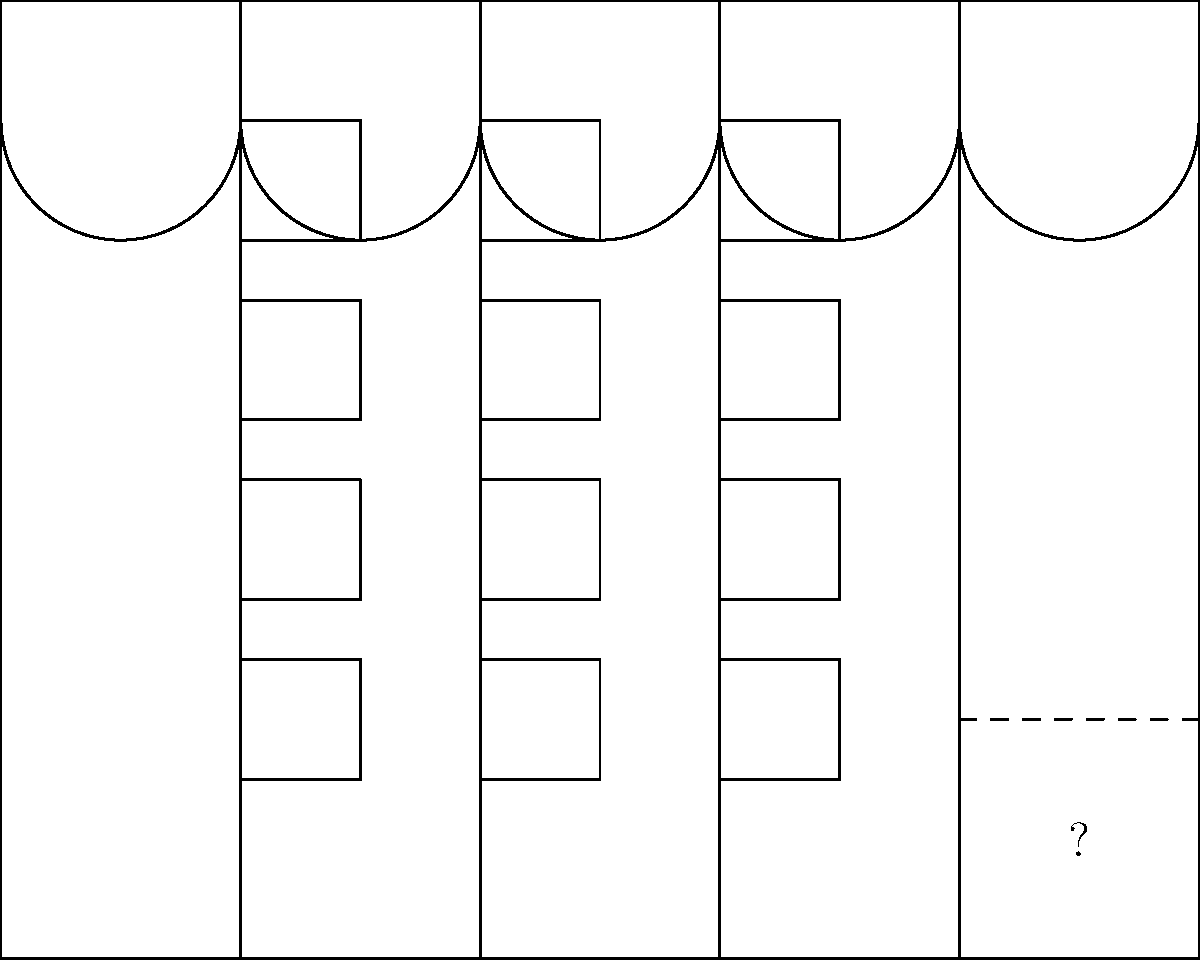In this visual puzzle of the original Penn Station facade, which architectural element is missing from the bottom right corner, as indicated by the dashed lines and question mark? To solve this puzzle, let's analyze the architectural elements of the facade:

1. The facade is symmetrical, with a rectangular shape.
2. There are columns evenly spaced across the facade.
3. Windows are arranged in a grid pattern between the columns.
4. Arches are present at the top of the facade between columns.
5. The bottom right corner (indicated by dashed lines and a question mark) is missing an element.

Looking at the overall structure:
- The left side of the facade has a solid base below the windows.
- This base extends from the ground to the bottom of the first row of windows.
- The right side should mirror the left for symmetry.

Therefore, the missing element in the bottom right corner would be:
- A continuation of the solid base
- Matching the height of the base on the left side
- Extending from the rightmost column to the edge of the facade

This element is often called a plinth or pedestal, which forms the base of the column and adds stability to the overall structure.
Answer: Plinth 